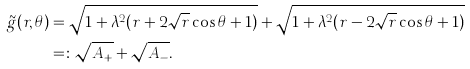<formula> <loc_0><loc_0><loc_500><loc_500>\tilde { g } ( r , \theta ) & = \sqrt { 1 + \lambda ^ { 2 } ( r + 2 \sqrt { r } \cos \theta + 1 ) } + \sqrt { 1 + \lambda ^ { 2 } ( r - 2 \sqrt { r } \cos \theta + 1 ) } \\ & = \colon \sqrt { A _ { + } } + \sqrt { A _ { - } } .</formula> 